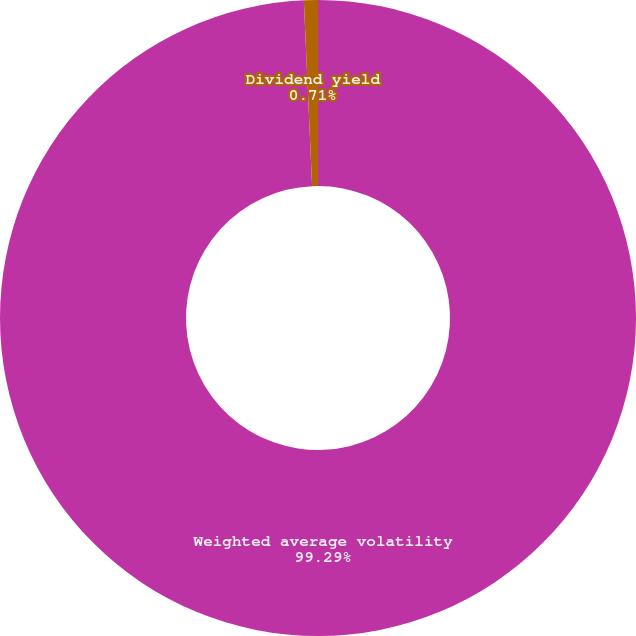<chart> <loc_0><loc_0><loc_500><loc_500><pie_chart><fcel>Weighted average volatility<fcel>Dividend yield<nl><fcel>99.29%<fcel>0.71%<nl></chart> 